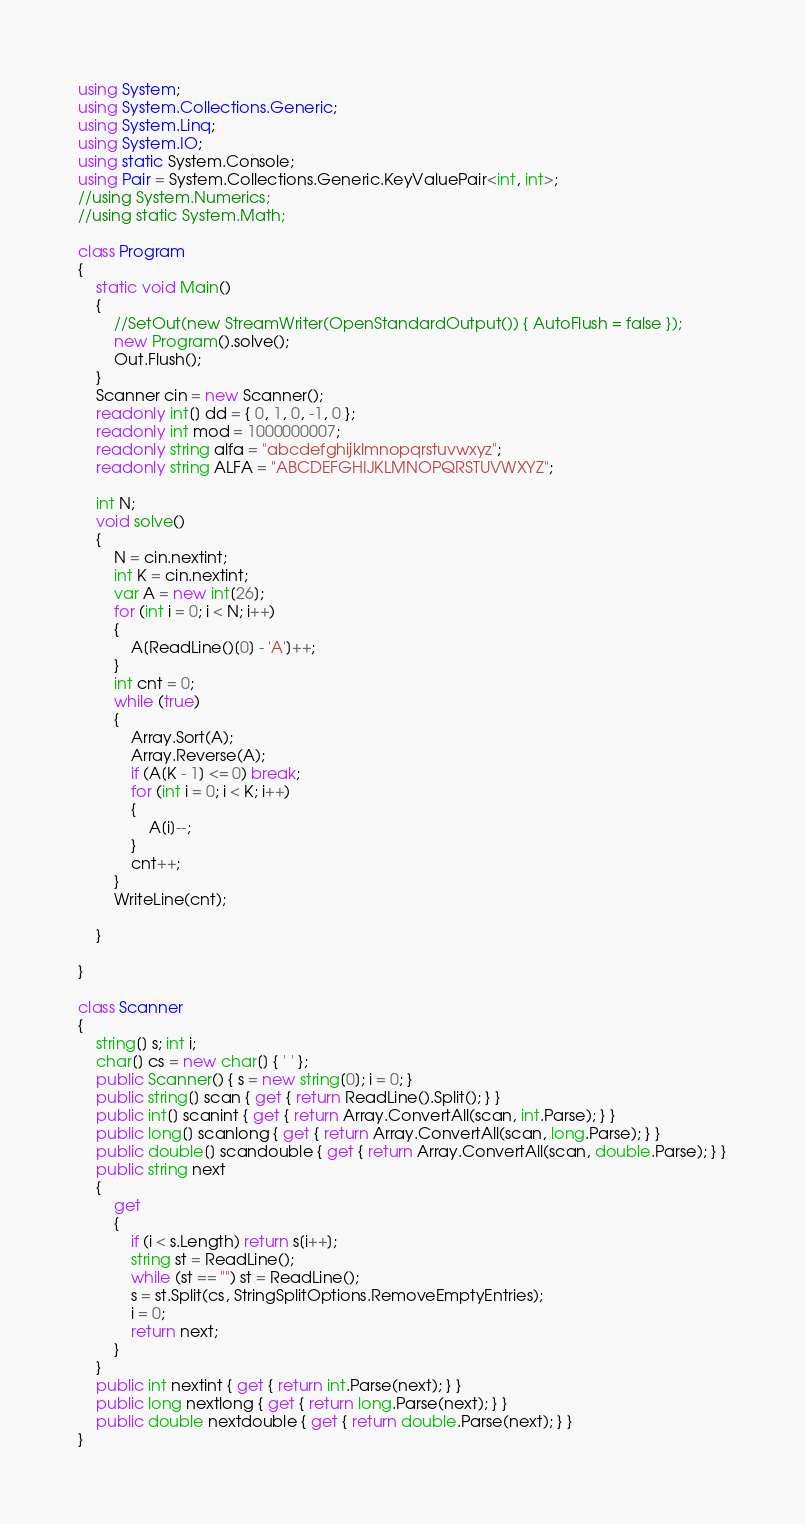<code> <loc_0><loc_0><loc_500><loc_500><_C#_>using System;
using System.Collections.Generic;
using System.Linq;
using System.IO;
using static System.Console;
using Pair = System.Collections.Generic.KeyValuePair<int, int>;
//using System.Numerics;
//using static System.Math;

class Program
{
    static void Main()
    {
        //SetOut(new StreamWriter(OpenStandardOutput()) { AutoFlush = false });
        new Program().solve();
        Out.Flush();
    }
    Scanner cin = new Scanner();
    readonly int[] dd = { 0, 1, 0, -1, 0 };
    readonly int mod = 1000000007;
    readonly string alfa = "abcdefghijklmnopqrstuvwxyz";
    readonly string ALFA = "ABCDEFGHIJKLMNOPQRSTUVWXYZ";

    int N;
    void solve()
    {
        N = cin.nextint;
        int K = cin.nextint;
        var A = new int[26];
        for (int i = 0; i < N; i++)
        {
            A[ReadLine()[0] - 'A']++;
        }
        int cnt = 0;
        while (true)
        {
            Array.Sort(A);
            Array.Reverse(A);
            if (A[K - 1] <= 0) break;
            for (int i = 0; i < K; i++)
            {
                A[i]--;
            }
            cnt++;
        }
        WriteLine(cnt);

    }

}

class Scanner
{
    string[] s; int i;
    char[] cs = new char[] { ' ' };
    public Scanner() { s = new string[0]; i = 0; }
    public string[] scan { get { return ReadLine().Split(); } }
    public int[] scanint { get { return Array.ConvertAll(scan, int.Parse); } }
    public long[] scanlong { get { return Array.ConvertAll(scan, long.Parse); } }
    public double[] scandouble { get { return Array.ConvertAll(scan, double.Parse); } }
    public string next
    {
        get
        {
            if (i < s.Length) return s[i++];
            string st = ReadLine();
            while (st == "") st = ReadLine();
            s = st.Split(cs, StringSplitOptions.RemoveEmptyEntries);
            i = 0;
            return next;
        }
    }
    public int nextint { get { return int.Parse(next); } }
    public long nextlong { get { return long.Parse(next); } }
    public double nextdouble { get { return double.Parse(next); } }
}</code> 